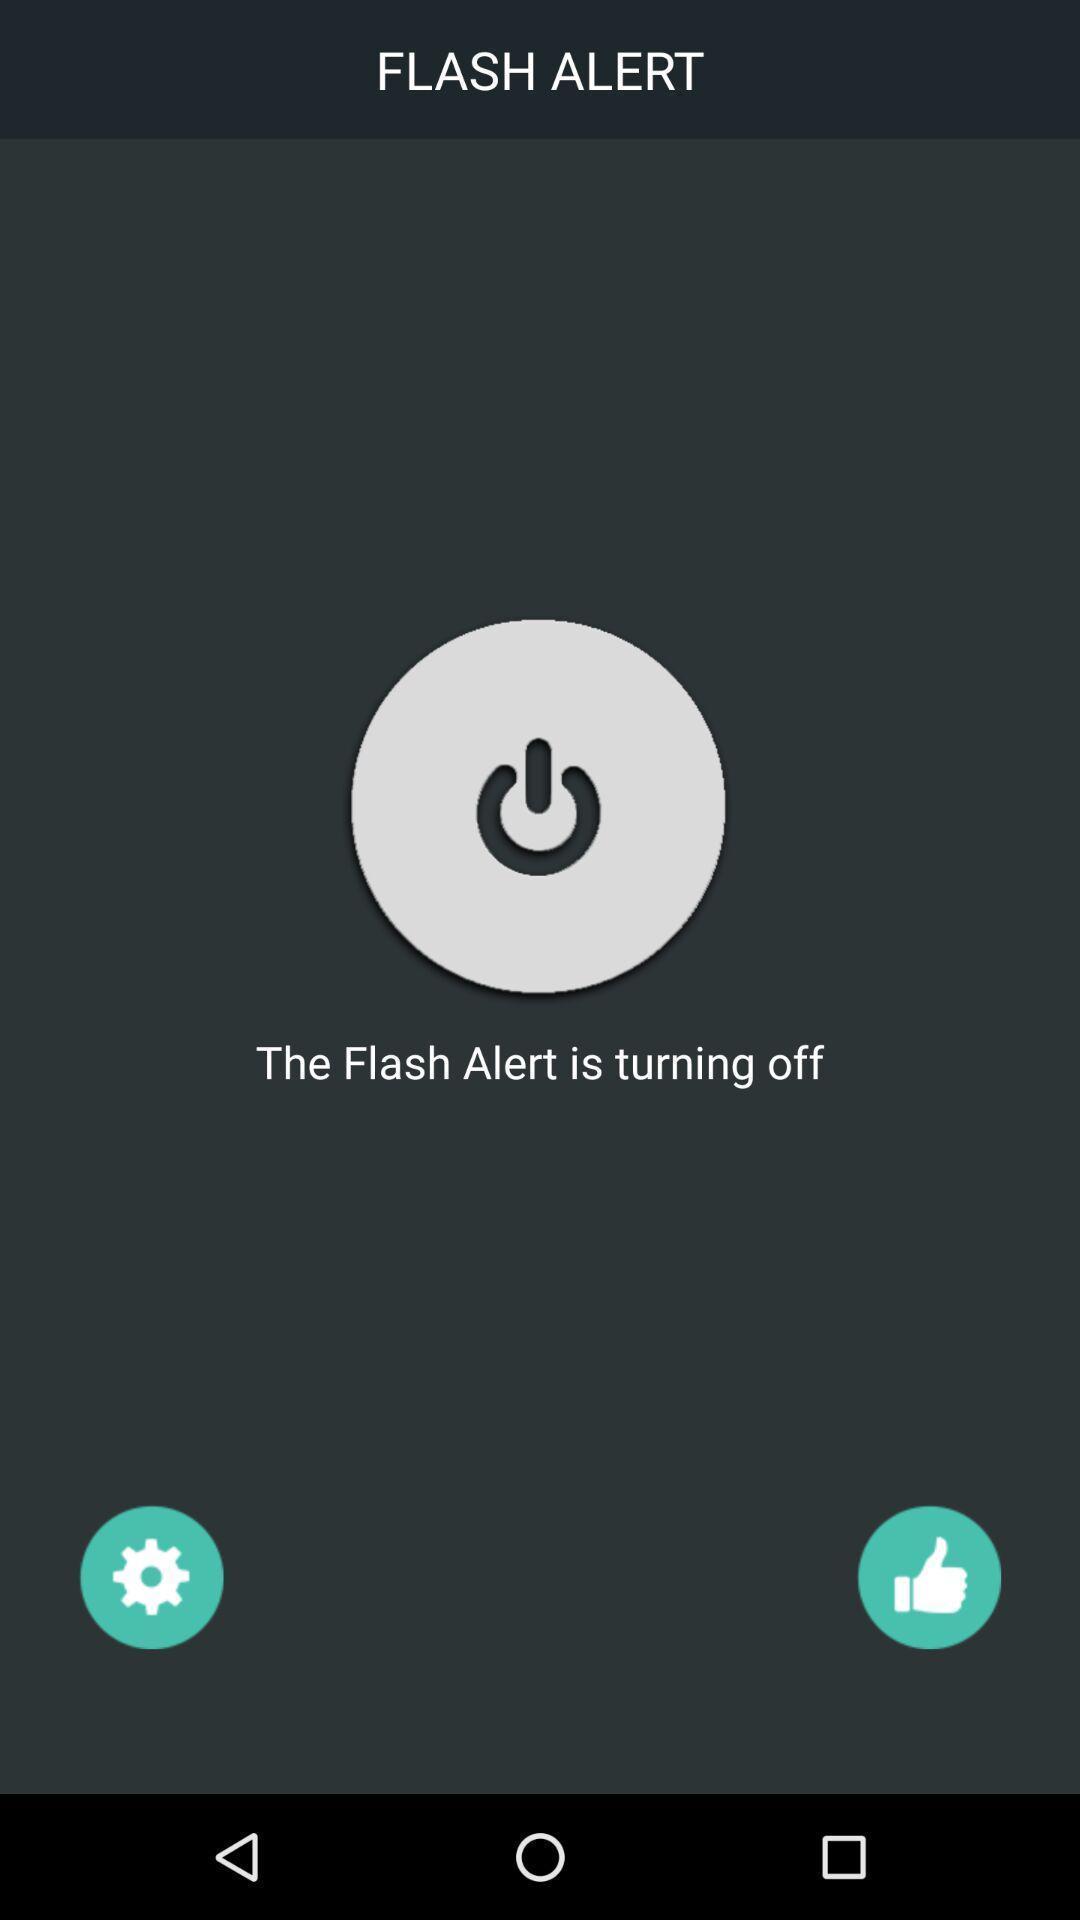Describe this image in words. Screen showing the flash alert is turning off. 